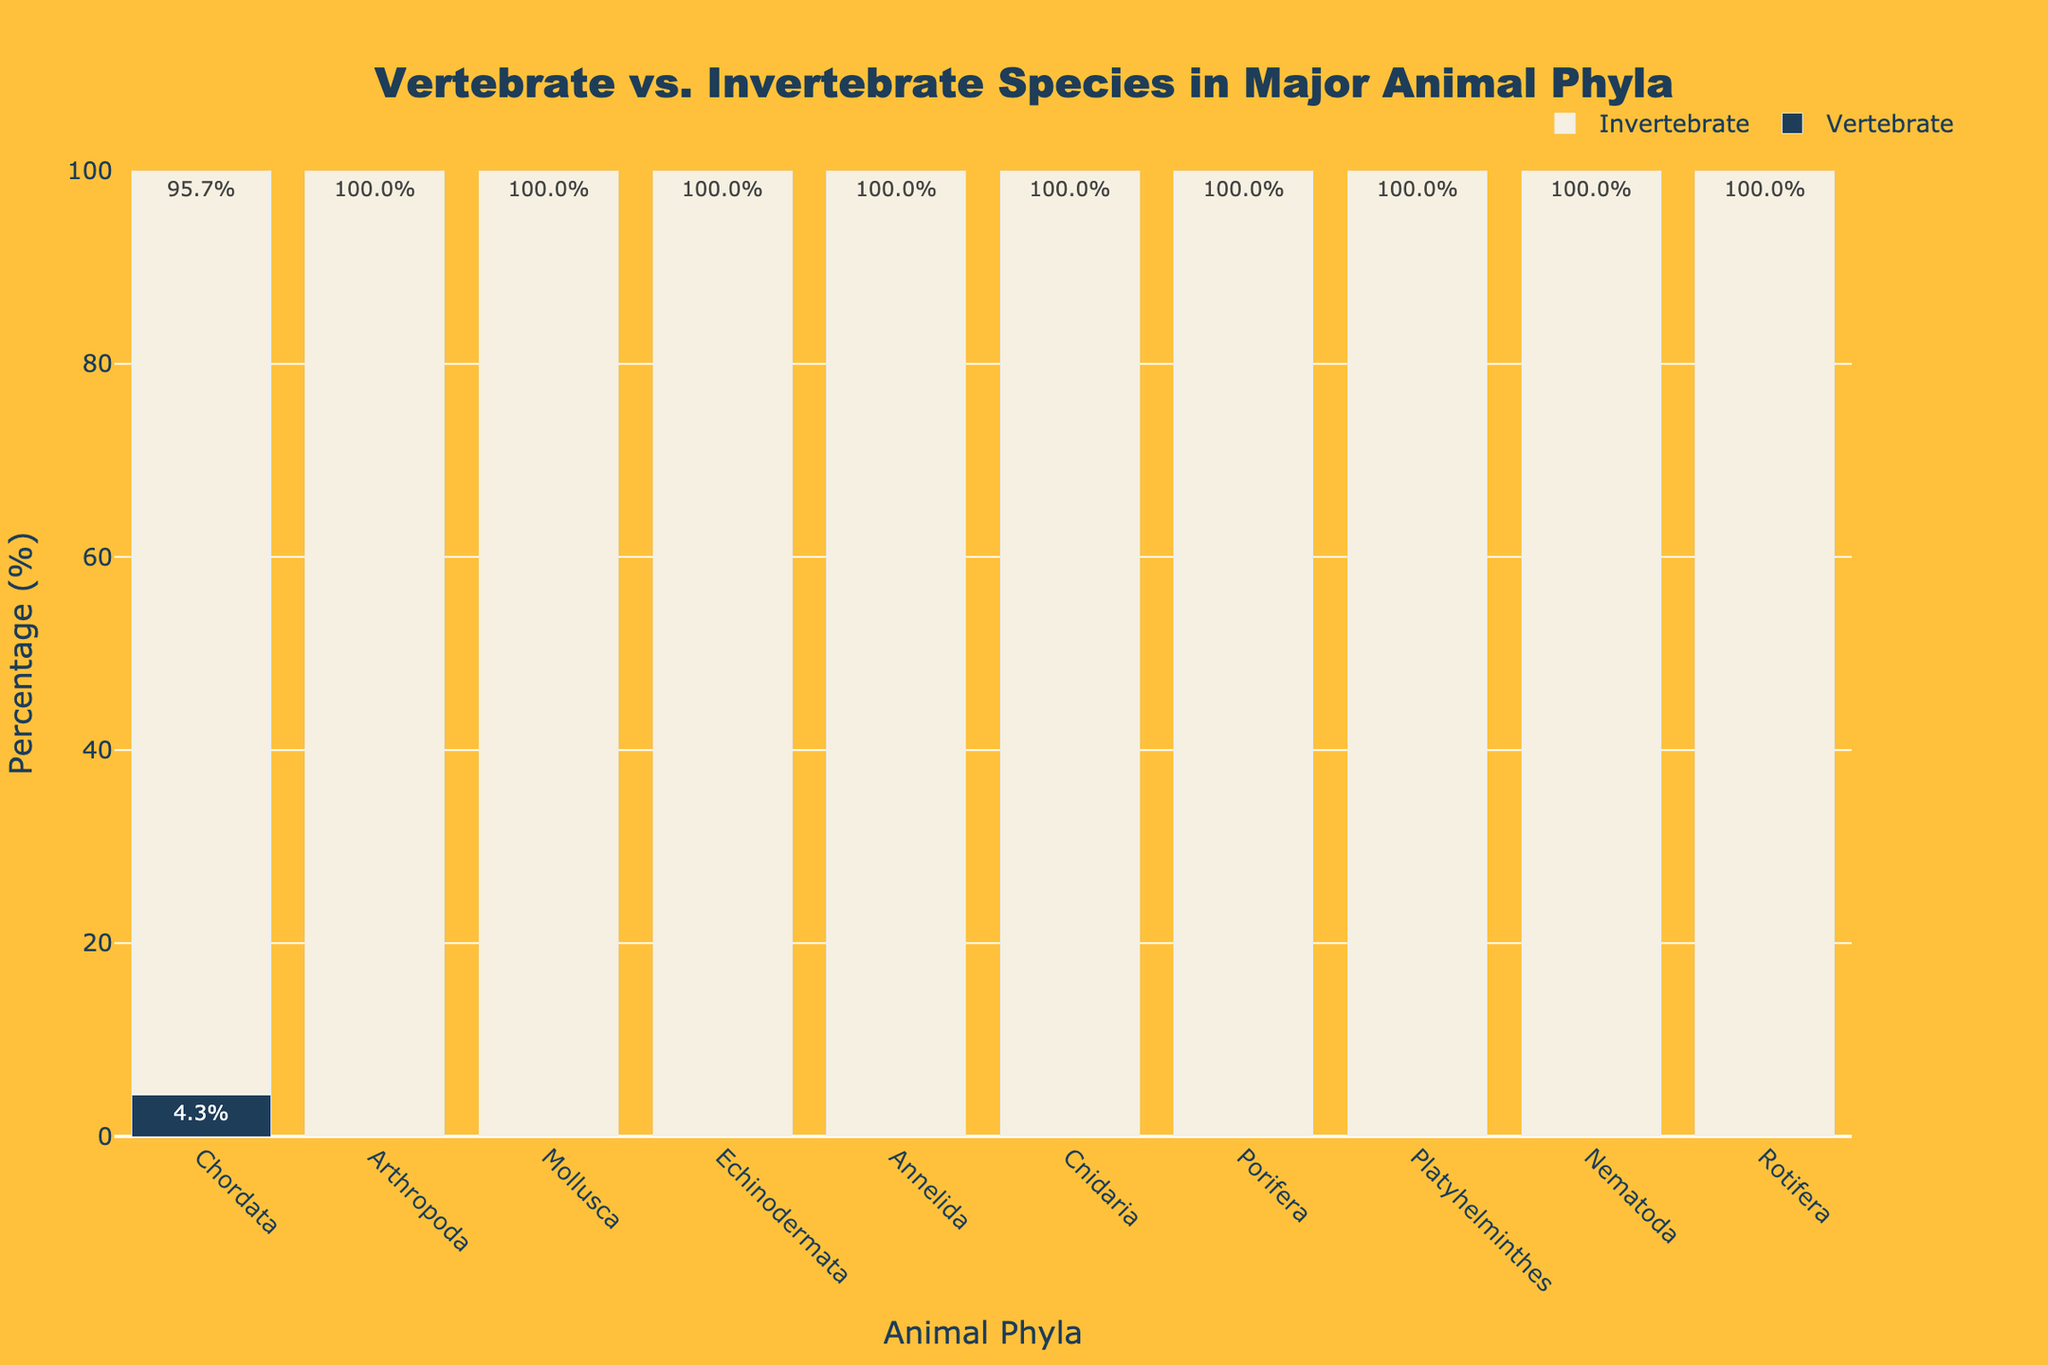What percentage of species in the phylum Chordata are vertebrates? According to the figure, the bar representing vertebrates in the phylum Chordata indicates a percentage value. The text inside the bar shows 4.3%, which means 4.3% of species in the phylum Chordata are vertebrates.
Answer: 4.3% Which phylum has 100% invertebrate species? By observing the bars labeled as "Invertebrate," all phyla except Chordata have bars indicating 100% invertebrates. Hence, Arthropoda, Mollusca, Echinodermata, Annelida, Cnidaria, Porifera, Platyhelminthes, Nematoda, and Rotifera have 100% invertebrate species.
Answer: Arthropoda, Mollusca, Echinodermata, Annelida, Cnidaria, Porifera, Platyhelminthes, Nematoda, Rotifera How many of the phyla listed contain no vertebrates at all? To determine the phyla with no vertebrates, we look for phyla where the "Vertebrate" bar indicates 0%. According to the figure, all phyla except Chordata have 0% vertebrates. Counting these gives us 9 phyla.
Answer: 9 What is the difference in the percentage of vertebrates between Chordata and Arthropoda? Chordata has a vertebrate percentage of 4.3% while Arthropoda has 0%. The difference is calculated by subtracting 0% from 4.3%, giving us 4.3%.
Answer: 4.3% Compare the phylum with the highest percentage of invertebrates to the phylum with the lowest percentage of invertebrates. What do you observe? All phyla except Chordata have an invertebrate percentage of 100%, while Chordata has an invertebrate percentage of 95.7%. Comparing these, Chordata has the lowest percentage of invertebrates, while the others have the highest (100%).
Answer: Chordata has the lowest percentage of invertebrates at 95.7%, others have 100% What color is used to represent vertebrate species in the figure? The bars representing vertebrate species in the figure are colored in a dark blue shade.
Answer: Dark blue If you were to average the percentage of vertebrates across all the phyla, what would the average be? Adding up the vertebrate percentages from all the phyla: (4.3 + 0 + 0 + 0 + 0 + 0 + 0 + 0 + 0 + 0) = 4.3. There are 10 phyla in total, so the average percentage is 4.3 / 10 = 0.43%.
Answer: 0.43% Which phylum has both the largest and smallest representation of vertebrates and invertebrates respectively? Chordata is the only phylum that has vertebrates represented (4.3%) and also has the smallest percentage of invertebrates (95.7%).
Answer: Chordata 